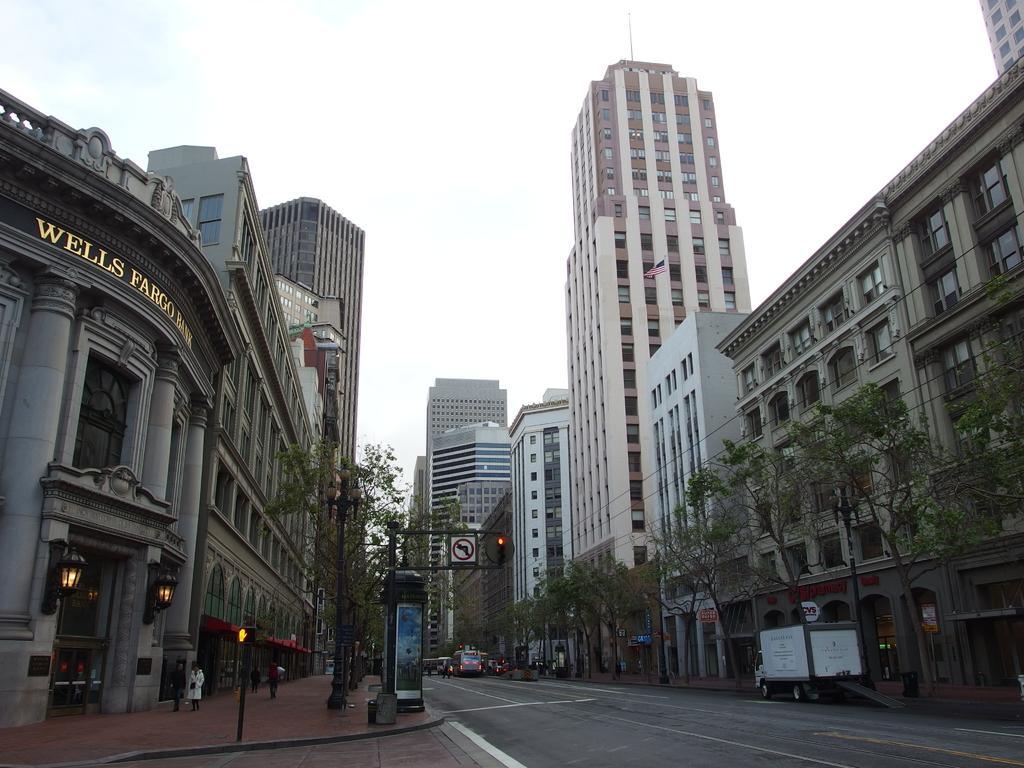In one or two sentences, can you explain what this image depicts? This picture shows few buildings and trees and we see few people walking on the sidewalk and we see vehicles on the road and a cloudy Sky. 